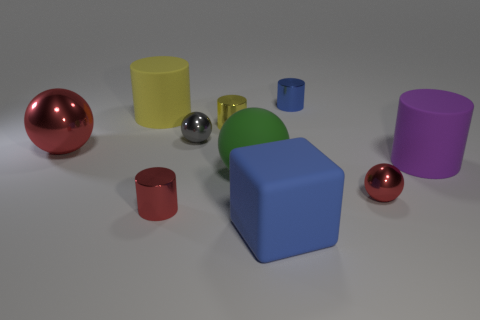There is a object that is the same color as the big block; what is its shape?
Give a very brief answer. Cylinder. What number of green things are the same shape as the small blue object?
Give a very brief answer. 0. What size is the gray sphere that is the same material as the big red ball?
Offer a terse response. Small. Is the green ball the same size as the gray ball?
Your answer should be compact. No. Are there any yellow rubber cylinders?
Provide a succinct answer. Yes. What is the size of the shiny thing that is the same color as the rubber block?
Ensure brevity in your answer.  Small. There is a yellow cylinder to the right of the big cylinder behind the red ball that is to the left of the large green rubber sphere; what is its size?
Provide a succinct answer. Small. What number of big cubes have the same material as the green object?
Offer a terse response. 1. What number of yellow objects are the same size as the red metal cylinder?
Make the answer very short. 1. What material is the red ball that is on the left side of the red shiny ball that is in front of the ball to the left of the large yellow cylinder?
Make the answer very short. Metal. 